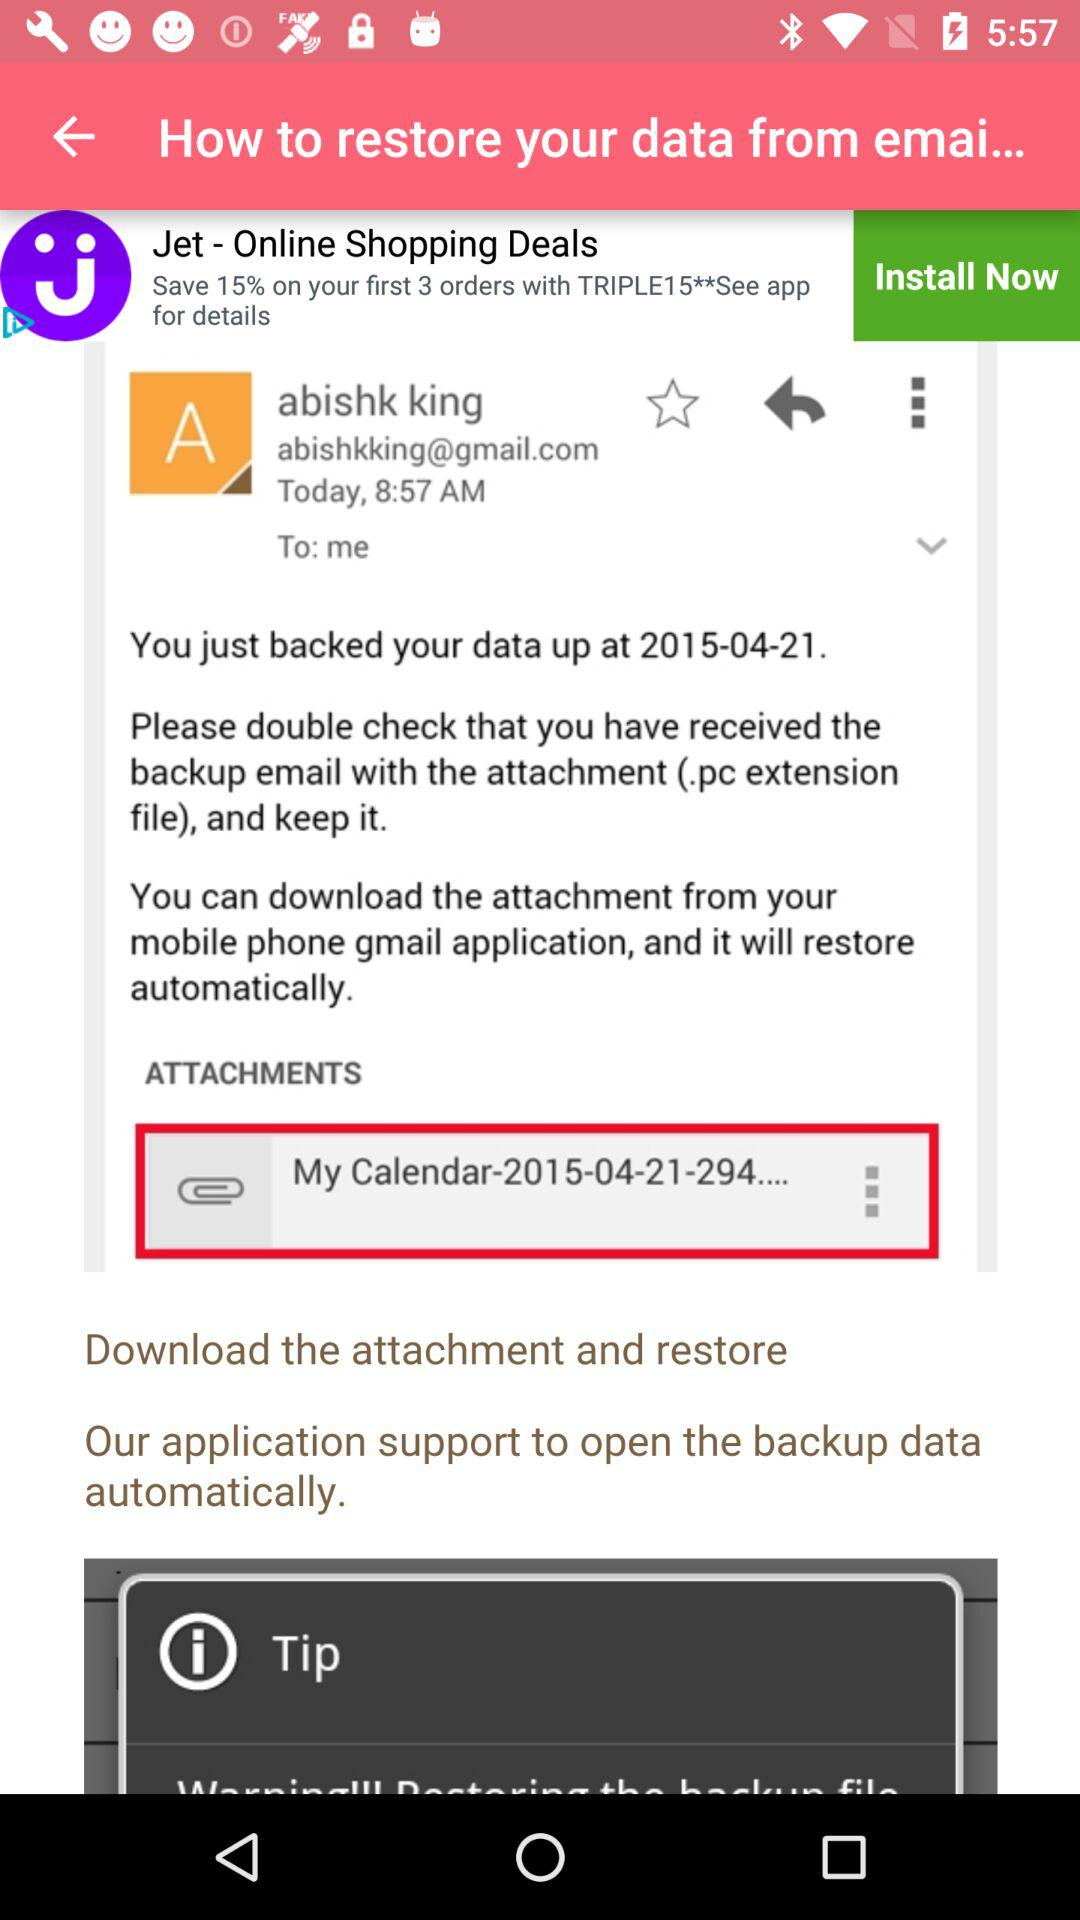When was the data backed up? The data was backed up on April 21, 2015. 